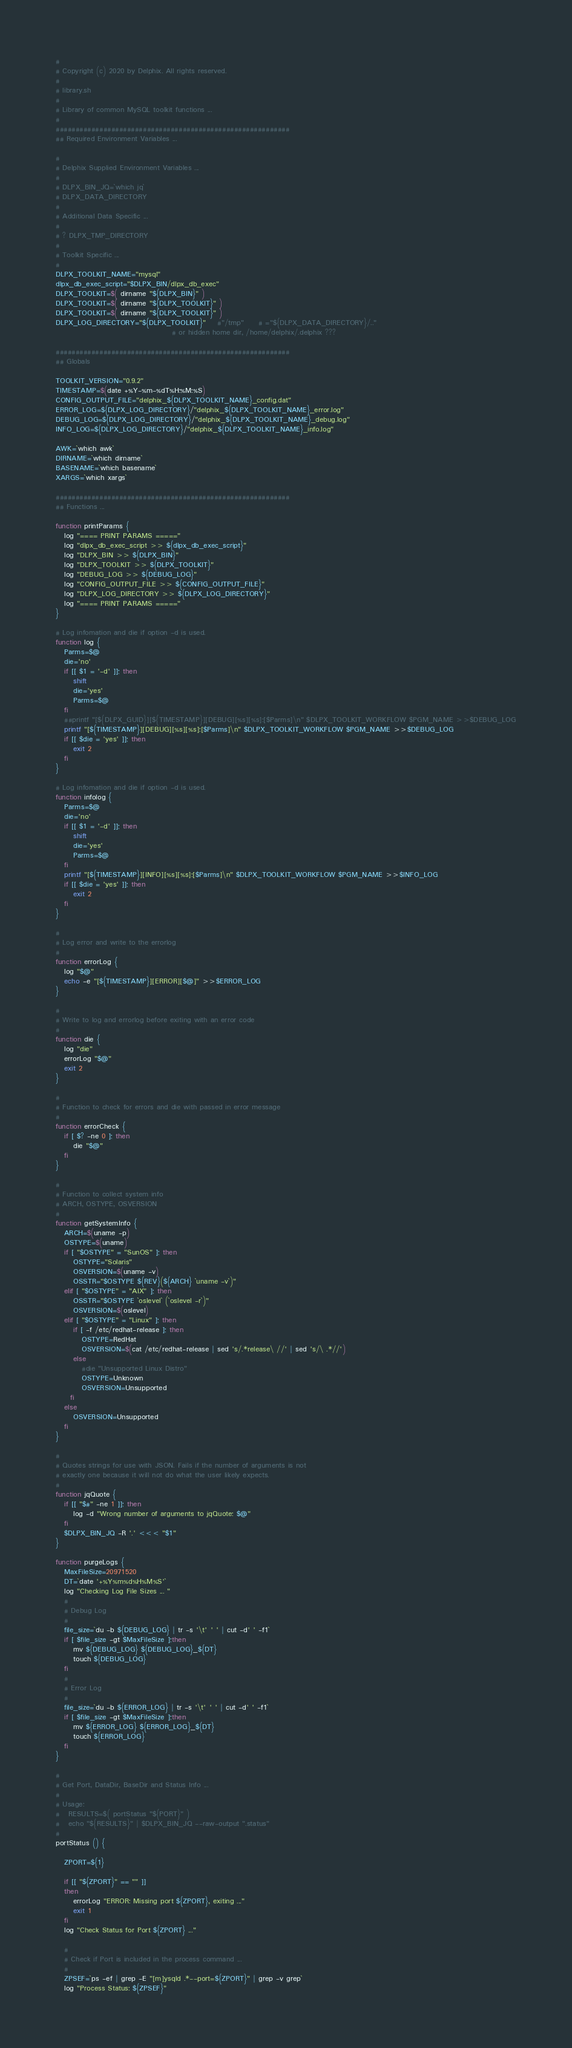Convert code to text. <code><loc_0><loc_0><loc_500><loc_500><_Bash_>#
# Copyright (c) 2020 by Delphix. All rights reserved.
#
# library.sh
#
# Library of common MySQL toolkit functions ... 
#
###########################################################
## Required Environment Variables ...

#
# Delphix Supplied Environment Variables ...
# 
# DLPX_BIN_JQ=`which jq`
# DLPX_DATA_DIRECTORY
# 
# Additional Data Specific ...
#
# ? DLPX_TMP_DIRECTORY
#
# Toolkit Specific ...
# 
DLPX_TOOLKIT_NAME="mysql"
dlpx_db_exec_script="$DLPX_BIN/dlpx_db_exec"
DLPX_TOOLKIT=$( dirname "${DLPX_BIN}" )
DLPX_TOOLKIT=$( dirname "${DLPX_TOOLKIT}" )
DLPX_TOOLKIT=$( dirname "${DLPX_TOOLKIT}" )
DLPX_LOG_DIRECTORY="${DLPX_TOOLKIT}" 	#"/tmp"     # ="${DLPX_DATA_DIRECTORY}/.."
                                        # or hidden home dir, /home/delphix/.delphix ???

###########################################################
## Globals

TOOLKIT_VERSION="0.9.2"
TIMESTAMP=$(date +%Y-%m-%dT%H:%M:%S)
CONFIG_OUTPUT_FILE="delphix_${DLPX_TOOLKIT_NAME}_config.dat"
ERROR_LOG=${DLPX_LOG_DIRECTORY}/"delphix_${DLPX_TOOLKIT_NAME}_error.log"
DEBUG_LOG=${DLPX_LOG_DIRECTORY}/"delphix_${DLPX_TOOLKIT_NAME}_debug.log"
INFO_LOG=${DLPX_LOG_DIRECTORY}/"delphix_${DLPX_TOOLKIT_NAME}_info.log"

AWK=`which awk`
DIRNAME=`which dirname`
BASENAME=`which basename`
XARGS=`which xargs`

###########################################################
## Functions ...

function printParams {
   log "==== PRINT PARAMS ====="
   log "dlpx_db_exec_script >> ${dlpx_db_exec_script}"
   log "DLPX_BIN >> ${DLPX_BIN}"
   log "DLPX_TOOLKIT >> ${DLPX_TOOLKIT}"
   log "DEBUG_LOG >> ${DEBUG_LOG}"
   log "CONFIG_OUTPUT_FILE >> ${CONFIG_OUTPUT_FILE}"
   log "DLPX_LOG_DIRECTORY >> ${DLPX_LOG_DIRECTORY}"
   log "==== PRINT PARAMS ====="
}

# Log infomation and die if option -d is used.
function log {
   Parms=$@
   die='no'
   if [[ $1 = '-d' ]]; then
      shift
      die='yes'
      Parms=$@
   fi
   ##printf "[${DLPX_GUID}][${TIMESTAMP}][DEBUG][%s][%s]:[$Parms]\n" $DLPX_TOOLKIT_WORKFLOW $PGM_NAME >>$DEBUG_LOG
   printf "[${TIMESTAMP}][DEBUG][%s][%s]:[$Parms]\n" $DLPX_TOOLKIT_WORKFLOW $PGM_NAME >>$DEBUG_LOG
   if [[ $die = 'yes' ]]; then
      exit 2
   fi
}

# Log infomation and die if option -d is used.
function infolog {
   Parms=$@
   die='no'
   if [[ $1 = '-d' ]]; then
      shift
      die='yes'
      Parms=$@
   fi
   printf "[${TIMESTAMP}][INFO][%s][%s]:[$Parms]\n" $DLPX_TOOLKIT_WORKFLOW $PGM_NAME >>$INFO_LOG
   if [[ $die = 'yes' ]]; then
      exit 2
   fi
}

#
# Log error and write to the errorlog
#
function errorLog {
   log "$@"
   echo -e "[${TIMESTAMP}][ERROR][$@]" >>$ERROR_LOG
}

#
# Write to log and errorlog before exiting with an error code
#
function die {
   log "die"
   errorLog "$@"
   exit 2
}

#
# Function to check for errors and die with passed in error message
#
function errorCheck {
   if [ $? -ne 0 ]; then
      die "$@"
   fi
}

#
# Function to collect system info
# ARCH, OSTYPE, OSVERSION
#
function getSystemInfo {
   ARCH=$(uname -p)
   OSTYPE=$(uname)
   if [ "$OSTYPE" = "SunOS" ]; then
      OSTYPE="Solaris"
      OSVERSION=$(uname -v)
      OSSTR="$OSTYPE ${REV}(${ARCH} `uname -v`)"
   elif [ "$OSTYPE" = "AIX" ]; then
      OSSTR="$OSTYPE `oslevel` (`oslevel -r`)"
      OSVERSION=$(oslevel)
   elif [ "$OSTYPE" = "Linux" ]; then
      if [ -f /etc/redhat-release ]; then
         OSTYPE=RedHat
         OSVERSION=$(cat /etc/redhat-release | sed 's/.*release\ //' | sed 's/\ .*//')
      else
         #die "Unsupported Linux Distro"
         OSTYPE=Unknown
         OSVERSION=Unsupported
     fi
   else 
      OSVERSION=Unsupported
   fi
}

#
# Quotes strings for use with JSON. Fails if the number of arguments is not
# exactly one because it will not do what the user likely expects.
#
function jqQuote {
   if [[ "$#" -ne 1 ]]; then
      log -d "Wrong number of arguments to jqQuote: $@"
   fi
   $DLPX_BIN_JQ -R '.' <<< "$1"
}

function purgeLogs {
   MaxFileSize=20971520
   DT=`date '+%Y%m%d%H%M%S'`
   log "Checking Log File Sizes ... "
   #
   # Debug Log
   #
   file_size=`du -b ${DEBUG_LOG} | tr -s '\t' ' ' | cut -d' ' -f1`
   if [ $file_size -gt $MaxFileSize ];then
      mv ${DEBUG_LOG} ${DEBUG_LOG}_${DT}
      touch ${DEBUG_LOG}
   fi
   #
   # Error Log
   #
   file_size=`du -b ${ERROR_LOG} | tr -s '\t' ' ' | cut -d' ' -f1`
   if [ $file_size -gt $MaxFileSize ];then
      mv ${ERROR_LOG} ${ERROR_LOG}_${DT}
      touch ${ERROR_LOG}
   fi
}

#
# Get Port, DataDir, BaseDir and Status Info ...
#
# Usage:
#   RESULTS=$( portStatus "${PORT}" )
#   echo "${RESULTS}" | $DLPX_BIN_JQ --raw-output ".status"
#
portStatus () {

   ZPORT=${1}

   if [[ "${ZPORT}" == "" ]]
   then
      errorLog "ERROR: Missing port ${ZPORT}, exiting ..."
      exit 1
   fi
   log "Check Status for Port ${ZPORT} ..."

   #
   # Check if Port is included in the process command ...
   #
   ZPSEF=`ps -ef | grep -E "[m]ysqld .*--port=${ZPORT}" | grep -v grep`
   log "Process Status: ${ZPSEF}"
</code> 